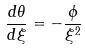<formula> <loc_0><loc_0><loc_500><loc_500>\frac { d \theta } { d \xi } = - \frac { \phi } { \xi ^ { 2 } }</formula> 